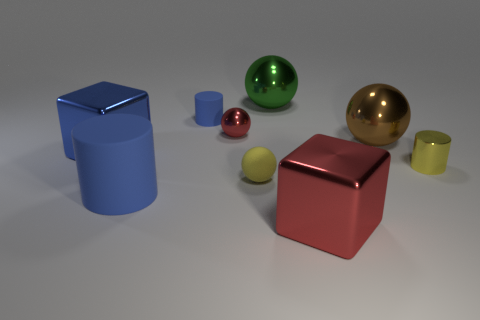There is a red metallic object in front of the red metallic sphere; what size is it?
Keep it short and to the point. Large. There is a small cylinder that is the same color as the tiny matte ball; what is its material?
Provide a succinct answer. Metal. The matte cylinder that is the same size as the green metal ball is what color?
Provide a short and direct response. Blue. Is the number of tiny things the same as the number of large green things?
Keep it short and to the point. No. Is the size of the red metallic sphere the same as the matte sphere?
Keep it short and to the point. Yes. There is a cylinder that is in front of the tiny red shiny sphere and behind the matte ball; how big is it?
Your answer should be very brief. Small. How many matte things are yellow balls or large green balls?
Provide a succinct answer. 1. Is the number of big blue matte cylinders that are right of the yellow metal cylinder greater than the number of blue spheres?
Provide a succinct answer. No. What is the brown ball that is in front of the green metal thing made of?
Provide a succinct answer. Metal. What number of red blocks are made of the same material as the green object?
Provide a short and direct response. 1. 